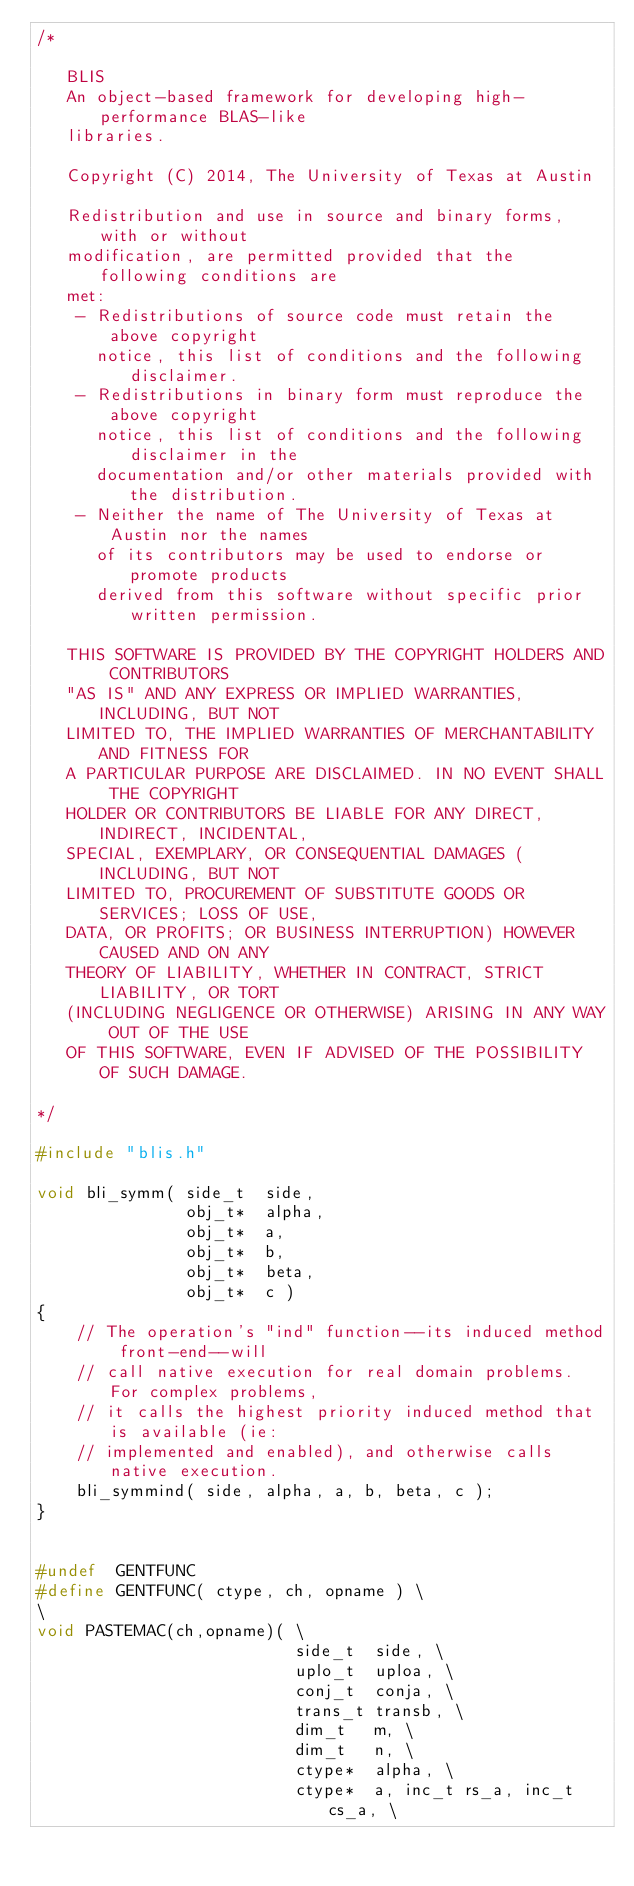<code> <loc_0><loc_0><loc_500><loc_500><_C_>/*

   BLIS    
   An object-based framework for developing high-performance BLAS-like
   libraries.

   Copyright (C) 2014, The University of Texas at Austin

   Redistribution and use in source and binary forms, with or without
   modification, are permitted provided that the following conditions are
   met:
    - Redistributions of source code must retain the above copyright
      notice, this list of conditions and the following disclaimer.
    - Redistributions in binary form must reproduce the above copyright
      notice, this list of conditions and the following disclaimer in the
      documentation and/or other materials provided with the distribution.
    - Neither the name of The University of Texas at Austin nor the names
      of its contributors may be used to endorse or promote products
      derived from this software without specific prior written permission.

   THIS SOFTWARE IS PROVIDED BY THE COPYRIGHT HOLDERS AND CONTRIBUTORS
   "AS IS" AND ANY EXPRESS OR IMPLIED WARRANTIES, INCLUDING, BUT NOT
   LIMITED TO, THE IMPLIED WARRANTIES OF MERCHANTABILITY AND FITNESS FOR
   A PARTICULAR PURPOSE ARE DISCLAIMED. IN NO EVENT SHALL THE COPYRIGHT
   HOLDER OR CONTRIBUTORS BE LIABLE FOR ANY DIRECT, INDIRECT, INCIDENTAL,
   SPECIAL, EXEMPLARY, OR CONSEQUENTIAL DAMAGES (INCLUDING, BUT NOT
   LIMITED TO, PROCUREMENT OF SUBSTITUTE GOODS OR SERVICES; LOSS OF USE,
   DATA, OR PROFITS; OR BUSINESS INTERRUPTION) HOWEVER CAUSED AND ON ANY
   THEORY OF LIABILITY, WHETHER IN CONTRACT, STRICT LIABILITY, OR TORT
   (INCLUDING NEGLIGENCE OR OTHERWISE) ARISING IN ANY WAY OUT OF THE USE
   OF THIS SOFTWARE, EVEN IF ADVISED OF THE POSSIBILITY OF SUCH DAMAGE.

*/

#include "blis.h"

void bli_symm( side_t  side,
               obj_t*  alpha,
               obj_t*  a,
               obj_t*  b,
               obj_t*  beta,
               obj_t*  c )
{
	// The operation's "ind" function--its induced method front-end--will
	// call native execution for real domain problems. For complex problems,
	// it calls the highest priority induced method that is available (ie:
	// implemented and enabled), and otherwise calls native execution.
	bli_symmind( side, alpha, a, b, beta, c );
}


#undef  GENTFUNC
#define GENTFUNC( ctype, ch, opname ) \
\
void PASTEMAC(ch,opname)( \
                          side_t  side, \
                          uplo_t  uploa, \
                          conj_t  conja, \
                          trans_t transb, \
                          dim_t   m, \
                          dim_t   n, \
                          ctype*  alpha, \
                          ctype*  a, inc_t rs_a, inc_t cs_a, \</code> 